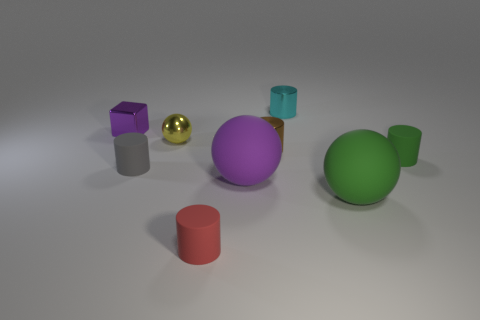There is a block; does it have the same color as the rubber sphere that is left of the brown cylinder?
Your answer should be very brief. Yes. What is the size of the matte sphere that is the same color as the tiny cube?
Provide a short and direct response. Large. Is the size of the purple thing behind the purple matte ball the same as the ball behind the brown metal object?
Ensure brevity in your answer.  Yes. What is the shape of the object that is both in front of the gray thing and on the right side of the tiny brown shiny object?
Your answer should be very brief. Sphere. Is there a big rubber thing that has the same color as the small shiny cube?
Provide a succinct answer. Yes. Are there any purple balls?
Your answer should be compact. Yes. There is a cylinder behind the small purple thing; what color is it?
Your response must be concise. Cyan. There is a yellow thing; is it the same size as the thing behind the cube?
Your response must be concise. Yes. What size is the object that is both left of the tiny red thing and in front of the small brown cylinder?
Offer a very short reply. Small. Is there a green ball that has the same material as the red cylinder?
Your answer should be very brief. Yes. 